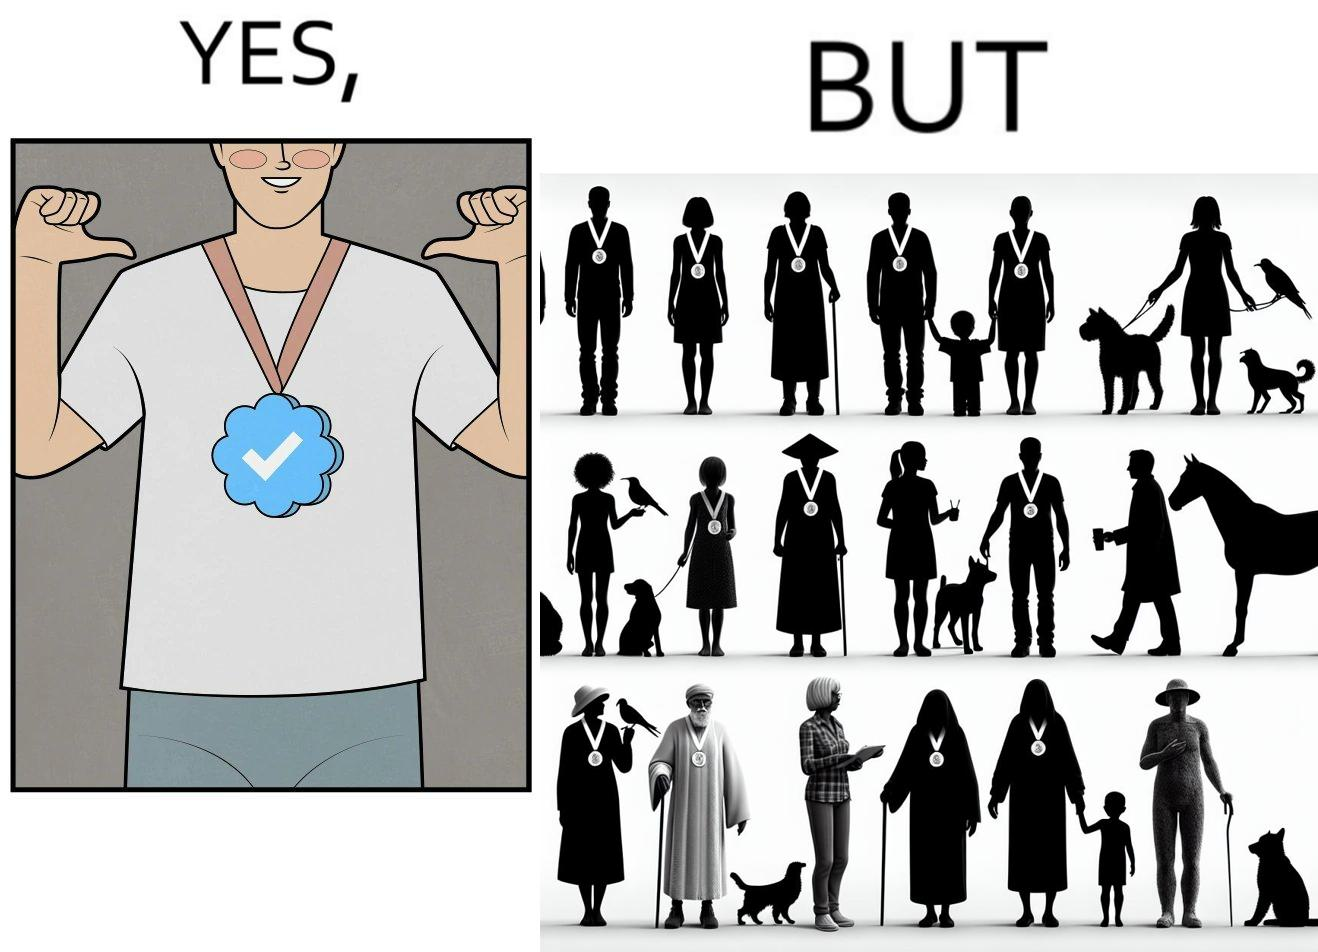Explain why this image is satirical. The images are funny since they show a man who thinks he has made a great achievement by winning a medal and is proud while everyone around him has the same medal and have achieved the same thing as he has 